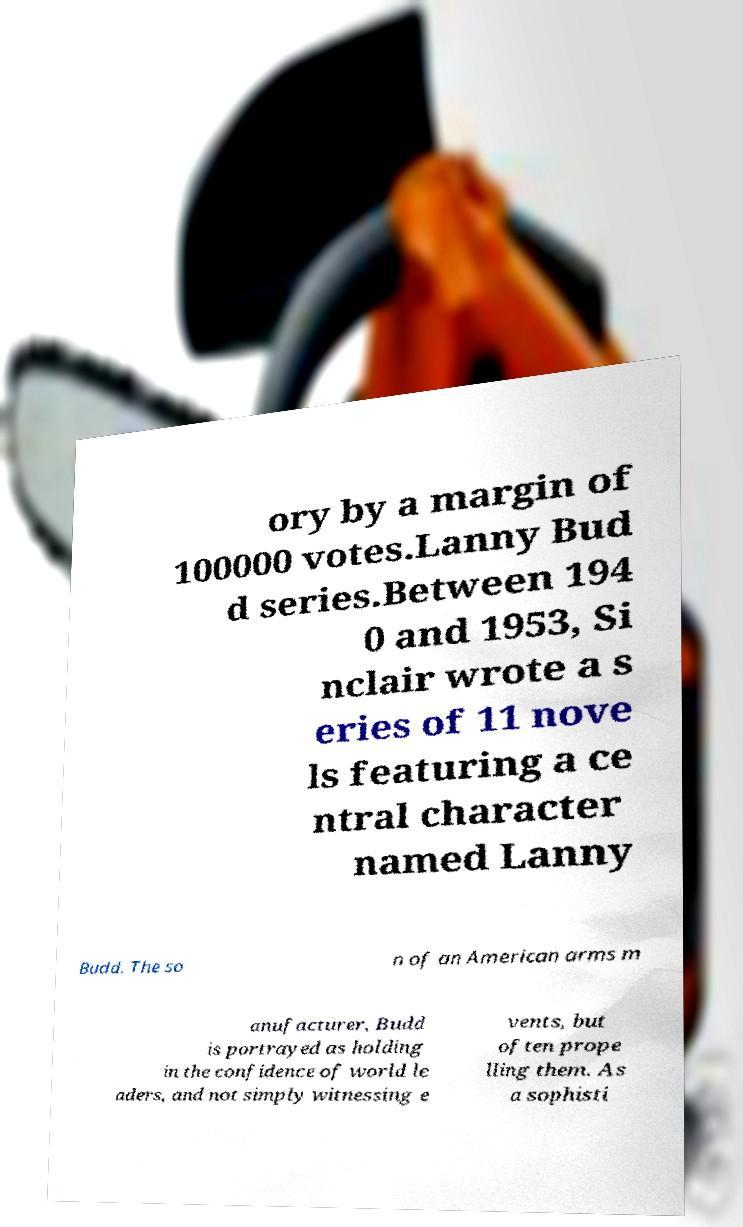Could you assist in decoding the text presented in this image and type it out clearly? ory by a margin of 100000 votes.Lanny Bud d series.Between 194 0 and 1953, Si nclair wrote a s eries of 11 nove ls featuring a ce ntral character named Lanny Budd. The so n of an American arms m anufacturer, Budd is portrayed as holding in the confidence of world le aders, and not simply witnessing e vents, but often prope lling them. As a sophisti 